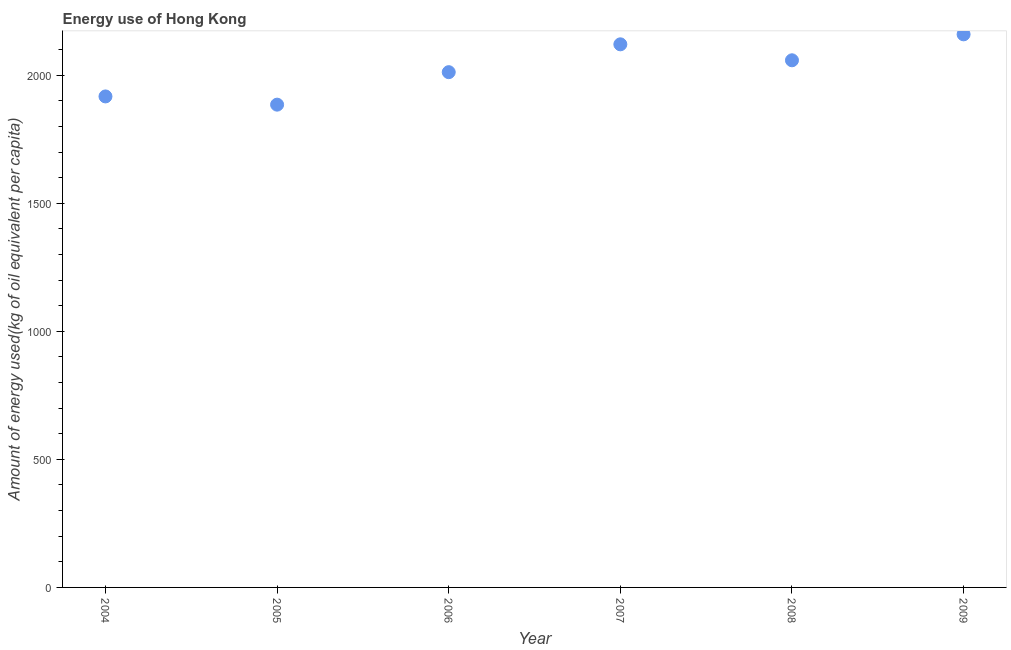What is the amount of energy used in 2006?
Your answer should be compact. 2011.84. Across all years, what is the maximum amount of energy used?
Your answer should be compact. 2159.52. Across all years, what is the minimum amount of energy used?
Make the answer very short. 1884.98. In which year was the amount of energy used maximum?
Give a very brief answer. 2009. In which year was the amount of energy used minimum?
Keep it short and to the point. 2005. What is the sum of the amount of energy used?
Your response must be concise. 1.22e+04. What is the difference between the amount of energy used in 2005 and 2006?
Your response must be concise. -126.86. What is the average amount of energy used per year?
Provide a succinct answer. 2025.36. What is the median amount of energy used?
Offer a very short reply. 2035.01. In how many years, is the amount of energy used greater than 800 kg?
Your answer should be compact. 6. What is the ratio of the amount of energy used in 2006 to that in 2007?
Your response must be concise. 0.95. Is the amount of energy used in 2004 less than that in 2005?
Give a very brief answer. No. Is the difference between the amount of energy used in 2004 and 2008 greater than the difference between any two years?
Make the answer very short. No. What is the difference between the highest and the second highest amount of energy used?
Offer a very short reply. 38.98. Is the sum of the amount of energy used in 2006 and 2008 greater than the maximum amount of energy used across all years?
Your answer should be very brief. Yes. What is the difference between the highest and the lowest amount of energy used?
Provide a succinct answer. 274.54. How many dotlines are there?
Offer a very short reply. 1. Does the graph contain any zero values?
Give a very brief answer. No. Does the graph contain grids?
Give a very brief answer. No. What is the title of the graph?
Ensure brevity in your answer.  Energy use of Hong Kong. What is the label or title of the X-axis?
Provide a short and direct response. Year. What is the label or title of the Y-axis?
Give a very brief answer. Amount of energy used(kg of oil equivalent per capita). What is the Amount of energy used(kg of oil equivalent per capita) in 2004?
Provide a succinct answer. 1917.1. What is the Amount of energy used(kg of oil equivalent per capita) in 2005?
Give a very brief answer. 1884.98. What is the Amount of energy used(kg of oil equivalent per capita) in 2006?
Your answer should be very brief. 2011.84. What is the Amount of energy used(kg of oil equivalent per capita) in 2007?
Make the answer very short. 2120.53. What is the Amount of energy used(kg of oil equivalent per capita) in 2008?
Keep it short and to the point. 2058.18. What is the Amount of energy used(kg of oil equivalent per capita) in 2009?
Provide a short and direct response. 2159.52. What is the difference between the Amount of energy used(kg of oil equivalent per capita) in 2004 and 2005?
Keep it short and to the point. 32.12. What is the difference between the Amount of energy used(kg of oil equivalent per capita) in 2004 and 2006?
Keep it short and to the point. -94.74. What is the difference between the Amount of energy used(kg of oil equivalent per capita) in 2004 and 2007?
Your answer should be very brief. -203.43. What is the difference between the Amount of energy used(kg of oil equivalent per capita) in 2004 and 2008?
Keep it short and to the point. -141.08. What is the difference between the Amount of energy used(kg of oil equivalent per capita) in 2004 and 2009?
Ensure brevity in your answer.  -242.42. What is the difference between the Amount of energy used(kg of oil equivalent per capita) in 2005 and 2006?
Your answer should be compact. -126.86. What is the difference between the Amount of energy used(kg of oil equivalent per capita) in 2005 and 2007?
Give a very brief answer. -235.56. What is the difference between the Amount of energy used(kg of oil equivalent per capita) in 2005 and 2008?
Provide a succinct answer. -173.2. What is the difference between the Amount of energy used(kg of oil equivalent per capita) in 2005 and 2009?
Keep it short and to the point. -274.54. What is the difference between the Amount of energy used(kg of oil equivalent per capita) in 2006 and 2007?
Your answer should be compact. -108.69. What is the difference between the Amount of energy used(kg of oil equivalent per capita) in 2006 and 2008?
Your response must be concise. -46.34. What is the difference between the Amount of energy used(kg of oil equivalent per capita) in 2006 and 2009?
Your answer should be very brief. -147.68. What is the difference between the Amount of energy used(kg of oil equivalent per capita) in 2007 and 2008?
Give a very brief answer. 62.36. What is the difference between the Amount of energy used(kg of oil equivalent per capita) in 2007 and 2009?
Make the answer very short. -38.98. What is the difference between the Amount of energy used(kg of oil equivalent per capita) in 2008 and 2009?
Make the answer very short. -101.34. What is the ratio of the Amount of energy used(kg of oil equivalent per capita) in 2004 to that in 2006?
Ensure brevity in your answer.  0.95. What is the ratio of the Amount of energy used(kg of oil equivalent per capita) in 2004 to that in 2007?
Offer a very short reply. 0.9. What is the ratio of the Amount of energy used(kg of oil equivalent per capita) in 2004 to that in 2009?
Your answer should be compact. 0.89. What is the ratio of the Amount of energy used(kg of oil equivalent per capita) in 2005 to that in 2006?
Ensure brevity in your answer.  0.94. What is the ratio of the Amount of energy used(kg of oil equivalent per capita) in 2005 to that in 2007?
Provide a short and direct response. 0.89. What is the ratio of the Amount of energy used(kg of oil equivalent per capita) in 2005 to that in 2008?
Offer a very short reply. 0.92. What is the ratio of the Amount of energy used(kg of oil equivalent per capita) in 2005 to that in 2009?
Your response must be concise. 0.87. What is the ratio of the Amount of energy used(kg of oil equivalent per capita) in 2006 to that in 2007?
Make the answer very short. 0.95. What is the ratio of the Amount of energy used(kg of oil equivalent per capita) in 2006 to that in 2009?
Your answer should be compact. 0.93. What is the ratio of the Amount of energy used(kg of oil equivalent per capita) in 2007 to that in 2009?
Keep it short and to the point. 0.98. What is the ratio of the Amount of energy used(kg of oil equivalent per capita) in 2008 to that in 2009?
Provide a succinct answer. 0.95. 